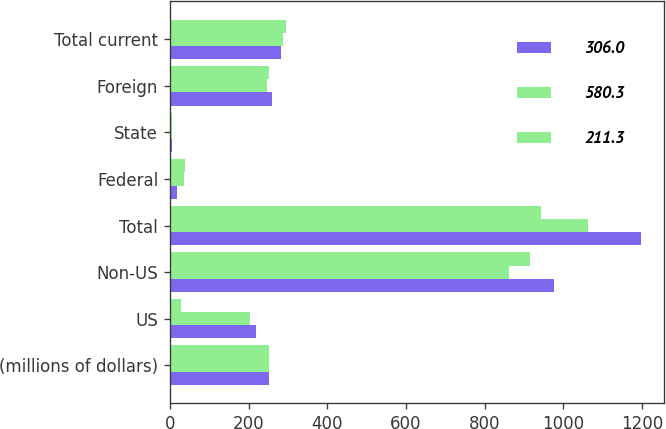Convert chart to OTSL. <chart><loc_0><loc_0><loc_500><loc_500><stacked_bar_chart><ecel><fcel>(millions of dollars)<fcel>US<fcel>Non-US<fcel>Total<fcel>Federal<fcel>State<fcel>Foreign<fcel>Total current<nl><fcel>306<fcel>251.7<fcel>220<fcel>975.9<fcel>1195.9<fcel>17.1<fcel>5.4<fcel>258.8<fcel>281.3<nl><fcel>580.3<fcel>251.7<fcel>203<fcel>860.6<fcel>1063.6<fcel>36.4<fcel>4.6<fcel>247.4<fcel>288.4<nl><fcel>211.3<fcel>251.7<fcel>27.5<fcel>915.2<fcel>942.7<fcel>37.4<fcel>6.1<fcel>251.7<fcel>295.2<nl></chart> 